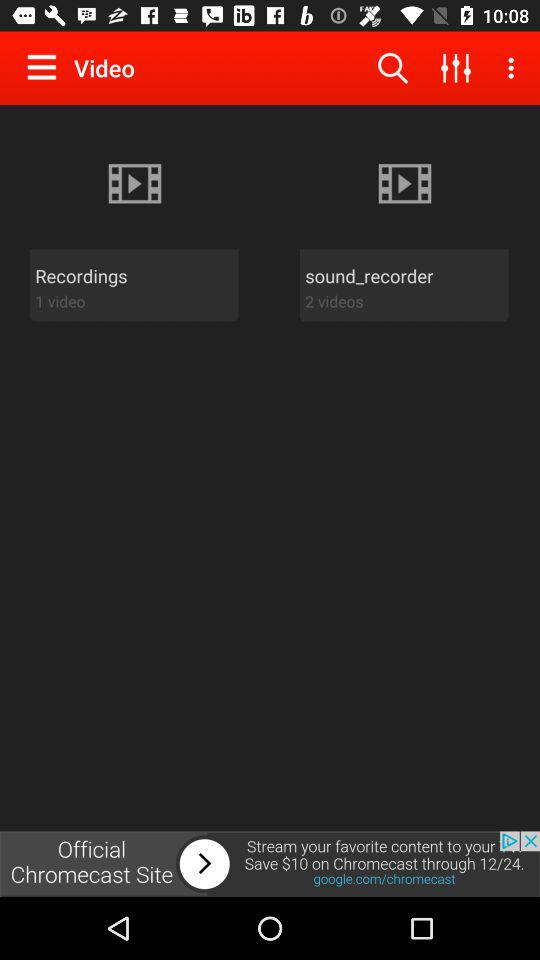What is the number of videos in "sound_recorder"? The number of videos in "sound_recorder" is 2. 